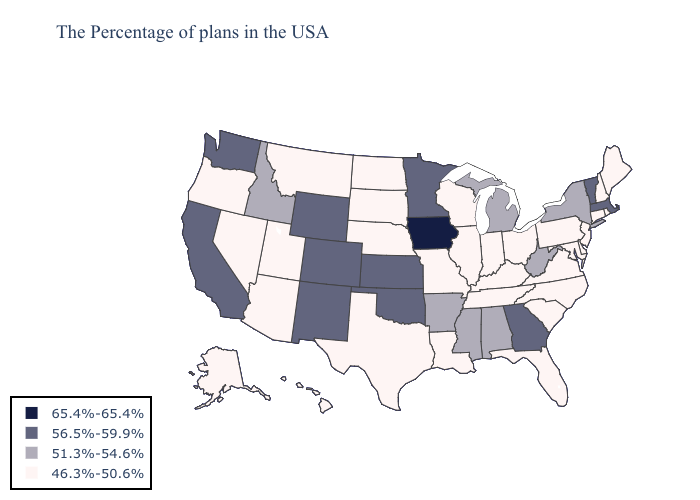Name the states that have a value in the range 51.3%-54.6%?
Give a very brief answer. New York, West Virginia, Michigan, Alabama, Mississippi, Arkansas, Idaho. Does Iowa have the highest value in the USA?
Short answer required. Yes. Among the states that border Iowa , does Minnesota have the lowest value?
Keep it brief. No. Which states hav the highest value in the West?
Write a very short answer. Wyoming, Colorado, New Mexico, California, Washington. Among the states that border Montana , which have the highest value?
Short answer required. Wyoming. Among the states that border Montana , which have the highest value?
Concise answer only. Wyoming. What is the highest value in the USA?
Quick response, please. 65.4%-65.4%. What is the lowest value in the South?
Give a very brief answer. 46.3%-50.6%. What is the value of Colorado?
Answer briefly. 56.5%-59.9%. Does South Carolina have the same value as Vermont?
Short answer required. No. What is the value of Ohio?
Concise answer only. 46.3%-50.6%. Does Pennsylvania have a lower value than Iowa?
Be succinct. Yes. What is the value of North Dakota?
Answer briefly. 46.3%-50.6%. 